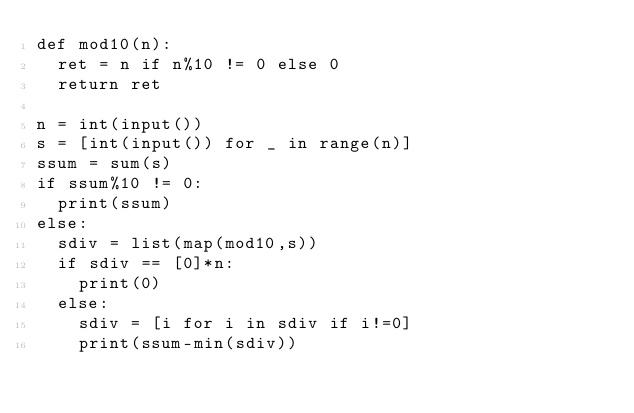Convert code to text. <code><loc_0><loc_0><loc_500><loc_500><_Python_>def mod10(n):
  ret = n if n%10 != 0 else 0
  return ret

n = int(input())
s = [int(input()) for _ in range(n)]
ssum = sum(s)
if ssum%10 != 0:
  print(ssum)
else:
  sdiv = list(map(mod10,s))
  if sdiv == [0]*n:
    print(0)
  else:
    sdiv = [i for i in sdiv if i!=0]
    print(ssum-min(sdiv))</code> 